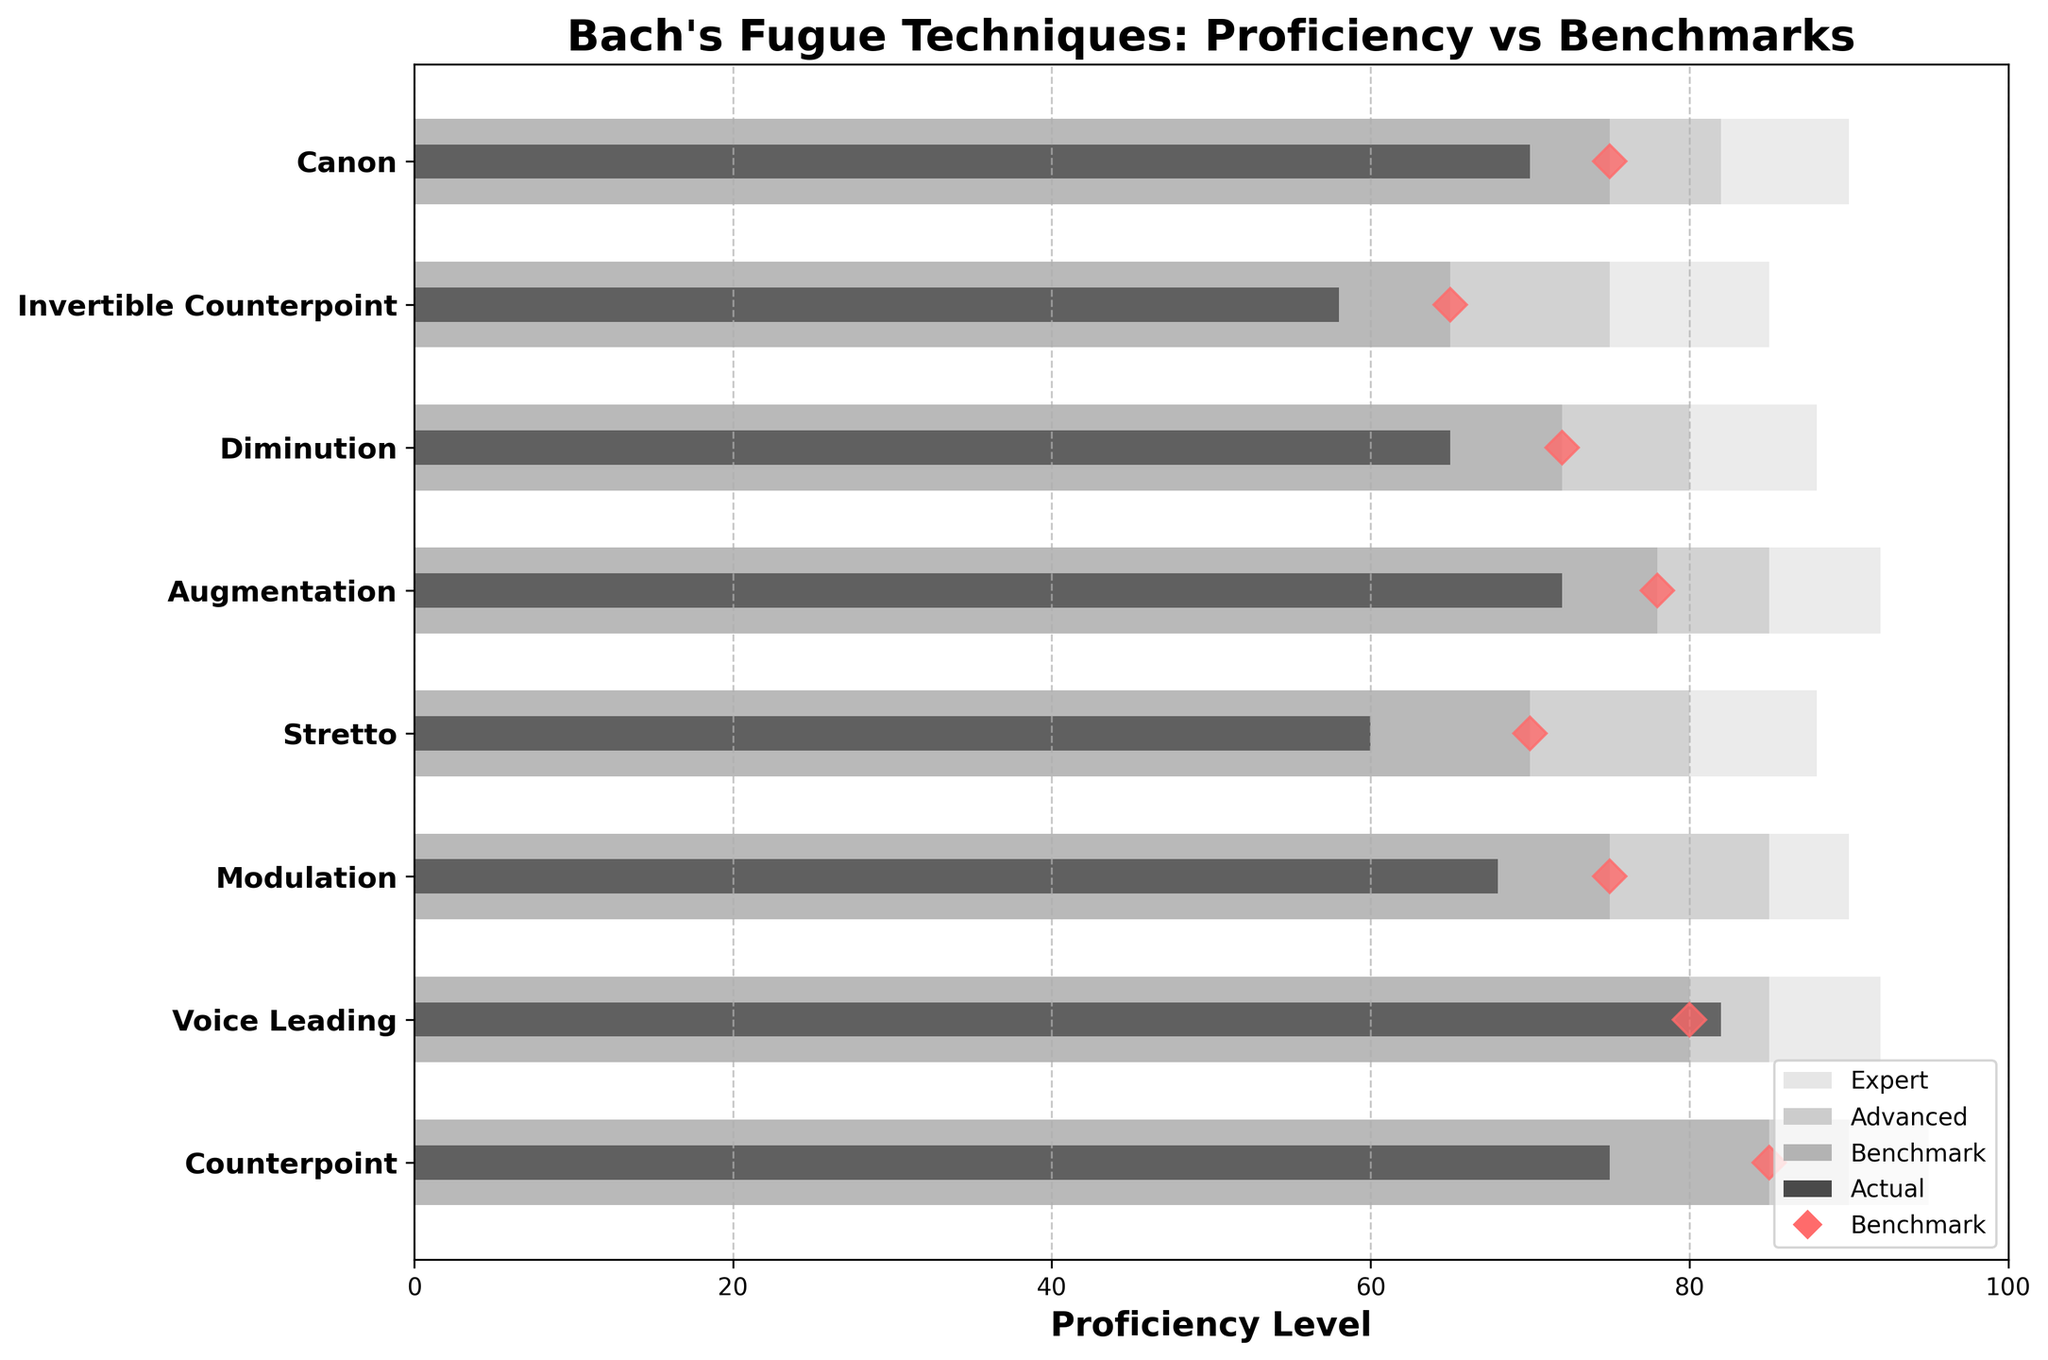What is the title of the plot? The title is located at the top of the plot and typically describes what the plot shows in a concise manner.
Answer: Bach's Fugue Techniques: Proficiency vs Benchmarks What is the proficiency level of the Voice Leading technique compared to the advanced benchmark? By looking at the bars corresponding to the "Voice Leading" technique, identify the "Actual" bar and the "Advanced" benchmark bar to make a comparison.
Answer: 82 vs 85 Which technique has the highest actual proficiency level? Examine all the "Actual" bars and identify the one that reaches the highest value on the x-axis.
Answer: Voice Leading How many techniques have an actual proficiency level above their respective benchmarks? Check each technique's "Actual" bar and compare its length to the corresponding "Benchmark" bar, then count how many of these are longer.
Answer: 1 Which technique has the lowest actual proficiency level? Examine all the "Actual" bars and identify the one that reaches the lowest value on the x-axis.
Answer: Invertible Counterpoint What is the difference between the actual proficiency level and the expert benchmark for the Stretto technique? Locate the "Stretto" row, find the "Actual" and "Expert" bars, and subtract the "Actual" value from the "Expert" value.
Answer: 88 - 60 = 28 Which techniques have actual proficiency levels that do not meet the benchmark? Compare each technique's "Actual" bar with the respective "Benchmark" bar and list the ones where the "Actual" bar is shorter.
Answer: Counterpoint, Modulation, Stretto, Augmentation, Diminution, Invertible Counterpoint, Canon For the Canon technique, what is the value difference between the advanced and expert benchmarks? Locate the "Canon" row, find the "Advanced" and "Expert" benchmark bars, and subtract the "Advanced" value from the "Expert" value.
Answer: 90 - 82 = 8 How many techniques have exact benchmarks set at 75? Identify the value of the "Benchmark" bar for each technique and count how many are exactly at 75.
Answer: 3 Which technique shows the smallest gap between its actual proficiency level and its advanced benchmark? Calculate the difference between the "Actual" and "Advanced" values for each technique, then identify the smallest difference.
Answer: Voice Leading 